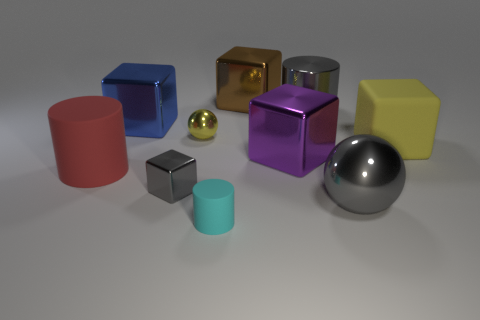Are the big cylinder that is right of the yellow metal sphere and the gray thing on the left side of the brown shiny cube made of the same material?
Ensure brevity in your answer.  Yes. The large shiny object that is the same color as the large shiny sphere is what shape?
Give a very brief answer. Cylinder. What number of gray objects are tiny matte things or cylinders?
Offer a terse response. 1. How big is the red object?
Offer a very short reply. Large. Is the number of gray metallic cylinders to the right of the small yellow metallic sphere greater than the number of shiny cylinders?
Your answer should be compact. No. There is a cyan object; how many yellow matte cubes are in front of it?
Ensure brevity in your answer.  0. Are there any gray shiny cylinders that have the same size as the blue object?
Keep it short and to the point. Yes. What is the color of the other matte object that is the same shape as the large red object?
Make the answer very short. Cyan. Does the matte cylinder that is on the left side of the big blue cube have the same size as the gray object that is behind the yellow cube?
Give a very brief answer. Yes. Is there a large blue thing of the same shape as the small yellow object?
Offer a terse response. No. 